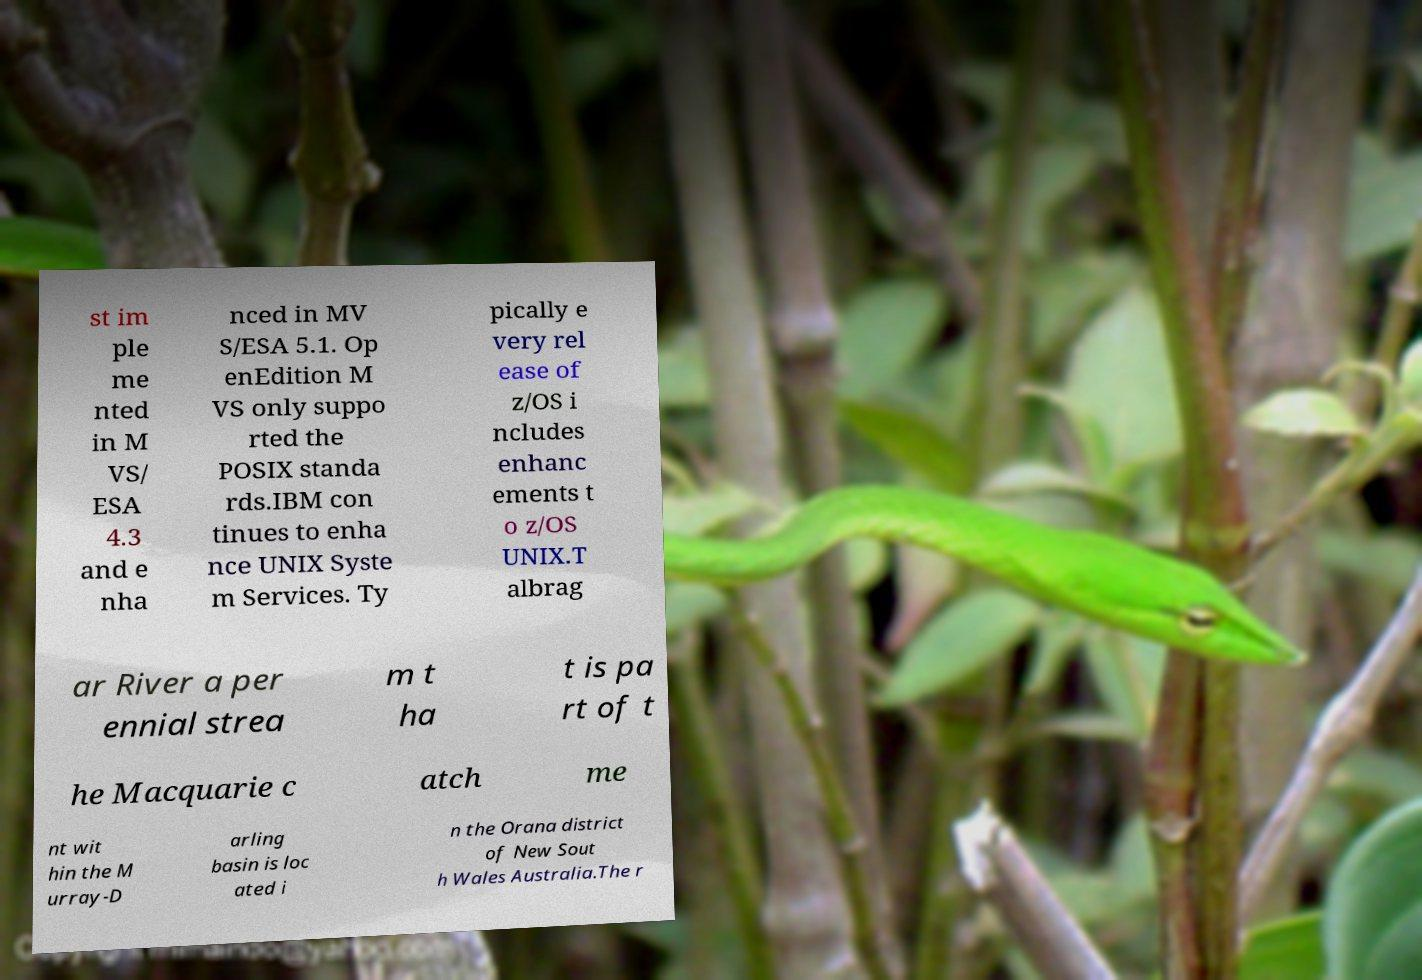Can you accurately transcribe the text from the provided image for me? st im ple me nted in M VS/ ESA 4.3 and e nha nced in MV S/ESA 5.1. Op enEdition M VS only suppo rted the POSIX standa rds.IBM con tinues to enha nce UNIX Syste m Services. Ty pically e very rel ease of z/OS i ncludes enhanc ements t o z/OS UNIX.T albrag ar River a per ennial strea m t ha t is pa rt of t he Macquarie c atch me nt wit hin the M urray-D arling basin is loc ated i n the Orana district of New Sout h Wales Australia.The r 